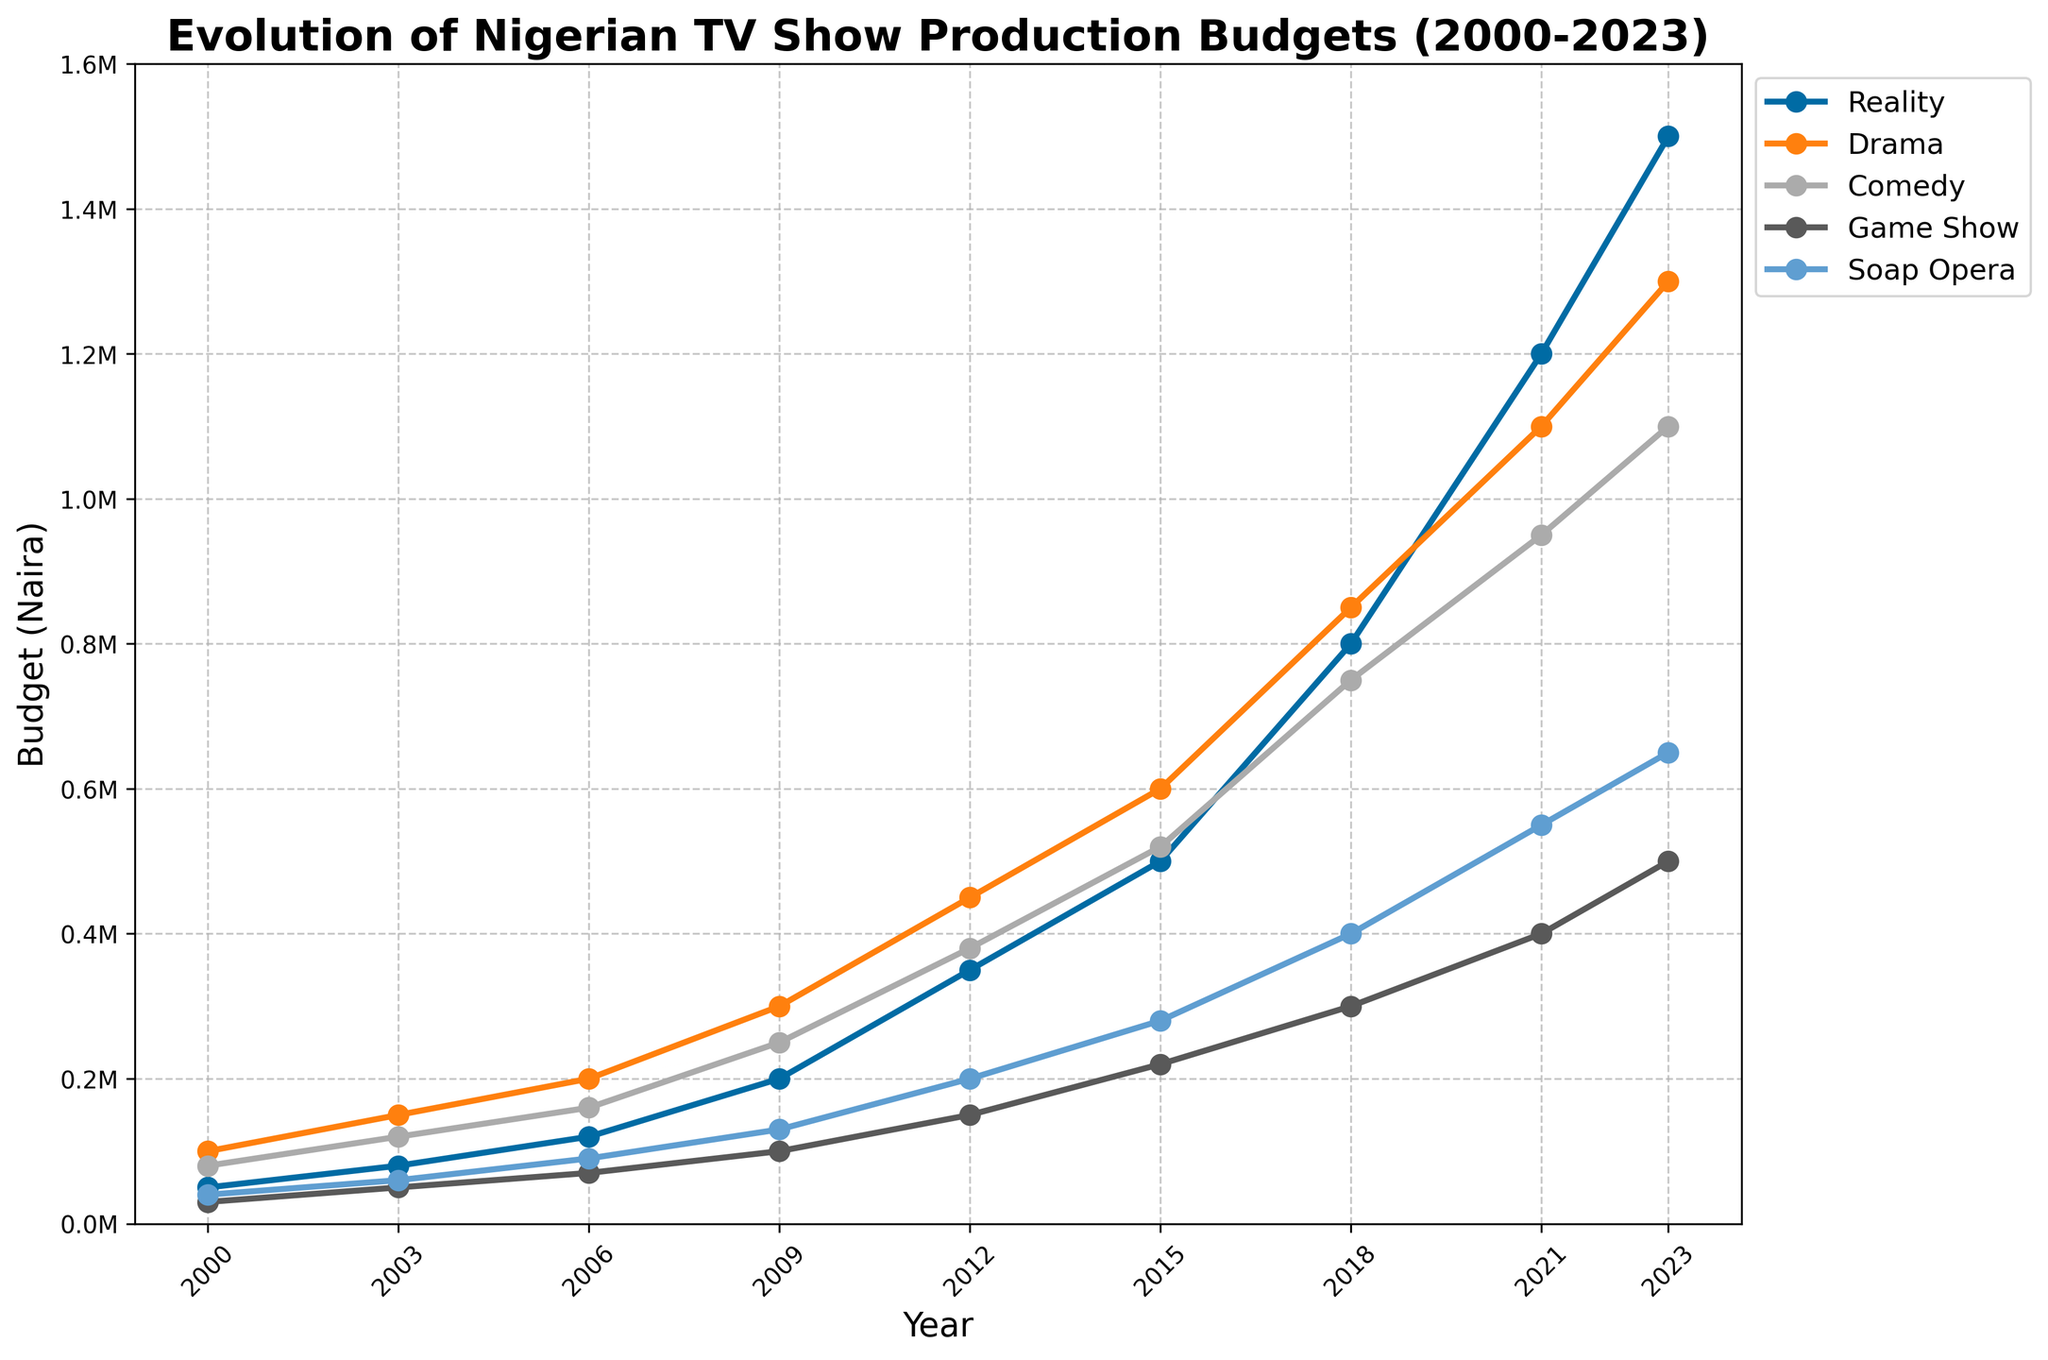Which genre had the highest production budget in 2023? Look at the data plot for the year 2023 and identify the genre with the highest budget value.
Answer: Reality Which genre showed the most consistent growth in production budget from 2000 to 2023? Assess each genre's budget trend line from 2000 to 2023 and identify which one shows the most consistent upward movement without large fluctuations.
Answer: Drama By how much did the budget for Reality TV shows increase from 2000 to 2023? Subtract the budget of Reality TV shows in 2000 from that in 2023 (1,500,000 - 50,000).
Answer: 1,450,000 What is the average production budget for Comedy shows over the years shown? Add up all the budget values for Comedy shows from 2000 to 2023 and divide by the number of data points (80,000 + 120,000 + 160,000 + 250,000 + 380,000 + 520,000 + 750,000 + 950,000 + 1,100,000) / 9.
Answer: 478,889 What is the percentage increase in the budget for Game Shows from 2000 to 2023? Subtract the 2000 budget from the 2023 budget for Game Shows, divide the result by the 2000 budget, and multiply by 100 ( [(500,000 - 30,000) / 30,000] * 100 ).
Answer: 1566.67% Which genre had the smallest budget in 2012? Identify the genre with the lowest plotted point in the year 2012.
Answer: Game Show How many times did the budget for Soap Operas increase from 2000 to 2023? Divide the budget for Soap Operas in 2023 by the budget in 2000 (650,000 / 40,000).
Answer: 16.25 Between which consecutive years did Drama shows see the largest absolute budget increase? Calculate the budget differences between each pair of consecutive years for Drama, and identify the pair with the largest difference (300,000 - 200,000 in 2006-2009).
Answer: 2006-2009 What is the trend of the budget for Reality TV shows from 2000 to 2023? Look at the plot and describe the general direction (upward/downward) and consistency of the budget trend line for Reality TV shows.
Answer: Upward, consistent In 2021, how did the budget for Soap Operas compare with that for Game Shows? Compare the vertical positions of the plotted points for Soap Operas and Game Shows in the year 2021.
Answer: Soap Operas had a higher budget 